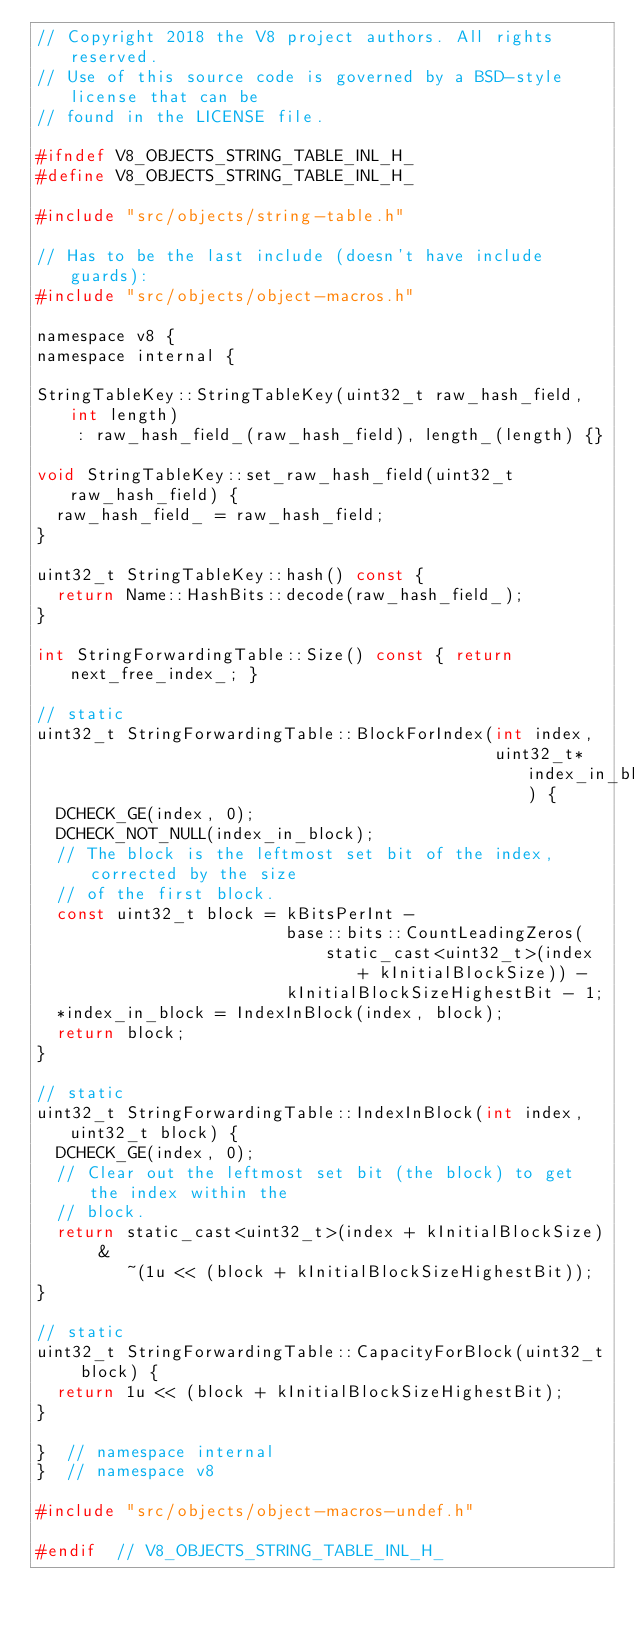Convert code to text. <code><loc_0><loc_0><loc_500><loc_500><_C_>// Copyright 2018 the V8 project authors. All rights reserved.
// Use of this source code is governed by a BSD-style license that can be
// found in the LICENSE file.

#ifndef V8_OBJECTS_STRING_TABLE_INL_H_
#define V8_OBJECTS_STRING_TABLE_INL_H_

#include "src/objects/string-table.h"

// Has to be the last include (doesn't have include guards):
#include "src/objects/object-macros.h"

namespace v8 {
namespace internal {

StringTableKey::StringTableKey(uint32_t raw_hash_field, int length)
    : raw_hash_field_(raw_hash_field), length_(length) {}

void StringTableKey::set_raw_hash_field(uint32_t raw_hash_field) {
  raw_hash_field_ = raw_hash_field;
}

uint32_t StringTableKey::hash() const {
  return Name::HashBits::decode(raw_hash_field_);
}

int StringForwardingTable::Size() const { return next_free_index_; }

// static
uint32_t StringForwardingTable::BlockForIndex(int index,
                                              uint32_t* index_in_block) {
  DCHECK_GE(index, 0);
  DCHECK_NOT_NULL(index_in_block);
  // The block is the leftmost set bit of the index, corrected by the size
  // of the first block.
  const uint32_t block = kBitsPerInt -
                         base::bits::CountLeadingZeros(
                             static_cast<uint32_t>(index + kInitialBlockSize)) -
                         kInitialBlockSizeHighestBit - 1;
  *index_in_block = IndexInBlock(index, block);
  return block;
}

// static
uint32_t StringForwardingTable::IndexInBlock(int index, uint32_t block) {
  DCHECK_GE(index, 0);
  // Clear out the leftmost set bit (the block) to get the index within the
  // block.
  return static_cast<uint32_t>(index + kInitialBlockSize) &
         ~(1u << (block + kInitialBlockSizeHighestBit));
}

// static
uint32_t StringForwardingTable::CapacityForBlock(uint32_t block) {
  return 1u << (block + kInitialBlockSizeHighestBit);
}

}  // namespace internal
}  // namespace v8

#include "src/objects/object-macros-undef.h"

#endif  // V8_OBJECTS_STRING_TABLE_INL_H_
</code> 